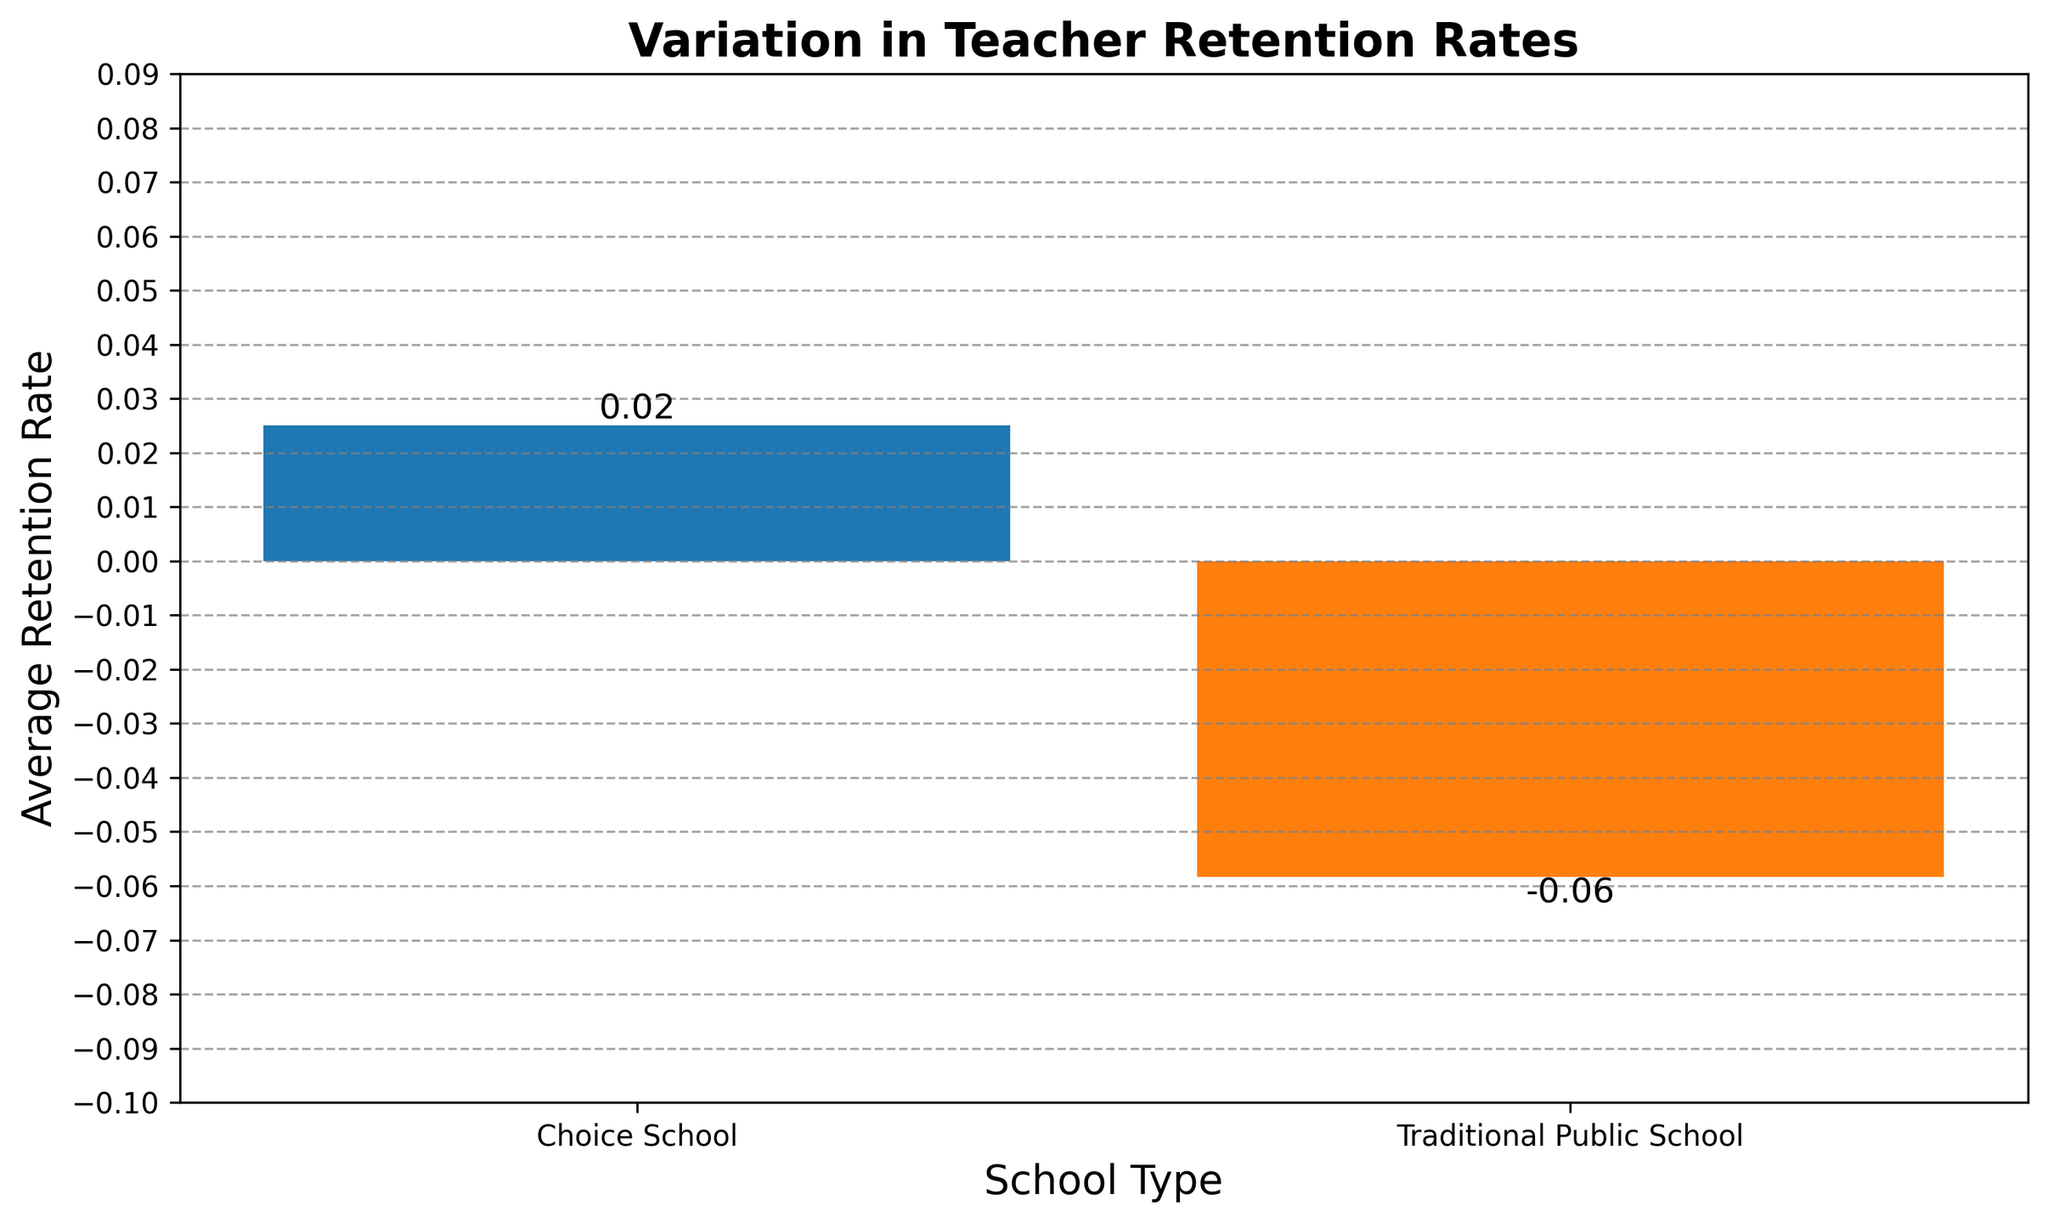What's the average teacher retention rate for Choice Schools? The figure shows the average teacher retention rate for Choice Schools. According to the visual information, the bar for Choice Schools represents approximately 0.025.
Answer: 0.025 Which type of school has a negative average retention rate? The bar representing Traditional Public Schools is below the zero line, indicating a negative average retention rate, whereas the bar for Choice Schools is above zero.
Answer: Traditional Public Schools What's the difference in average teacher retention rates between Traditional Public Schools and Choice Schools? The average retention rate for Choice Schools is about 0.025, while for Traditional Public Schools, it is approximately -0.055. The difference is calculated as (0.025 - (-0.055)) = 0.08.
Answer: 0.08 How much higher is the average teacher retention rate for Choice Schools compared to Traditional Public Schools? The average retention rate for Choice Schools is 0.025, and for Traditional Public Schools, it is -0.055. The difference (how much higher) is calculated by subtracting the Traditional Public Schools rate from the Choice Schools rate, 0.025 - (-0.055) = 0.08.
Answer: 0.08 Which bar is taller, representing a higher average retention rate? The bar for Choice Schools is taller, indicating a higher average retention rate compared to the bar for Traditional Public Schools.
Answer: Choice Schools Is any retention rate displayed as zero in the figure? In the figure, there are no bars positioned exactly at the zero line; they are either above or below it.
Answer: No What is the combined average retention rate if both school types are considered together? Average retention rates for Traditional Public Schools and Choice Schools are -0.055 and 0.025, respectively. The combined average retention rate = \(\frac{-0.055 + 0.025}{2} = -0.015\).
Answer: -0.015 Which school type shows a positive trend in teacher retention rates according to the figure? The bar for Choice Schools is above the zero line, indicating a positive trend in teacher retention rates.
Answer: Choice Schools 